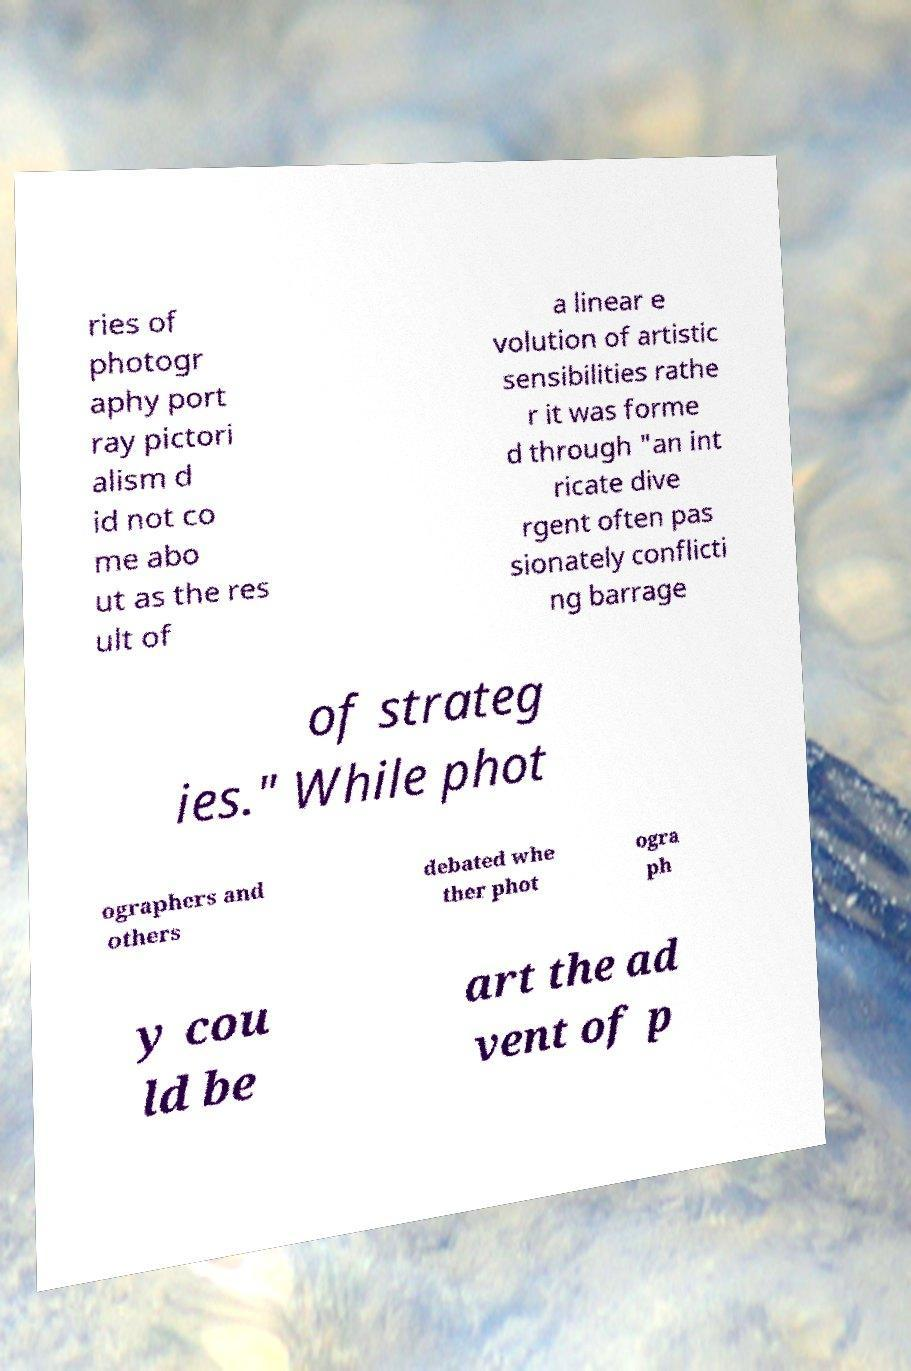Can you accurately transcribe the text from the provided image for me? ries of photogr aphy port ray pictori alism d id not co me abo ut as the res ult of a linear e volution of artistic sensibilities rathe r it was forme d through "an int ricate dive rgent often pas sionately conflicti ng barrage of strateg ies." While phot ographers and others debated whe ther phot ogra ph y cou ld be art the ad vent of p 